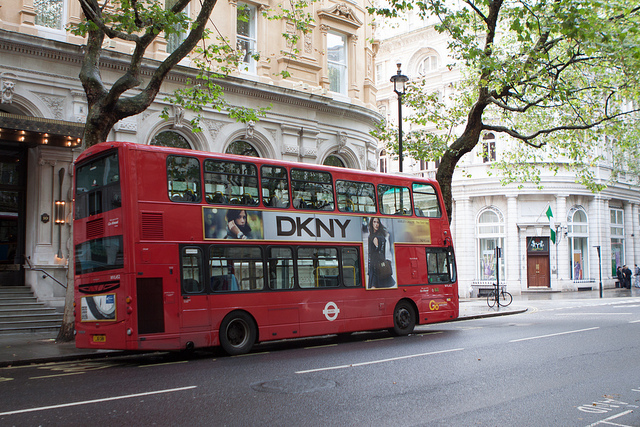Please transcribe the text information in this image. DKNY G 